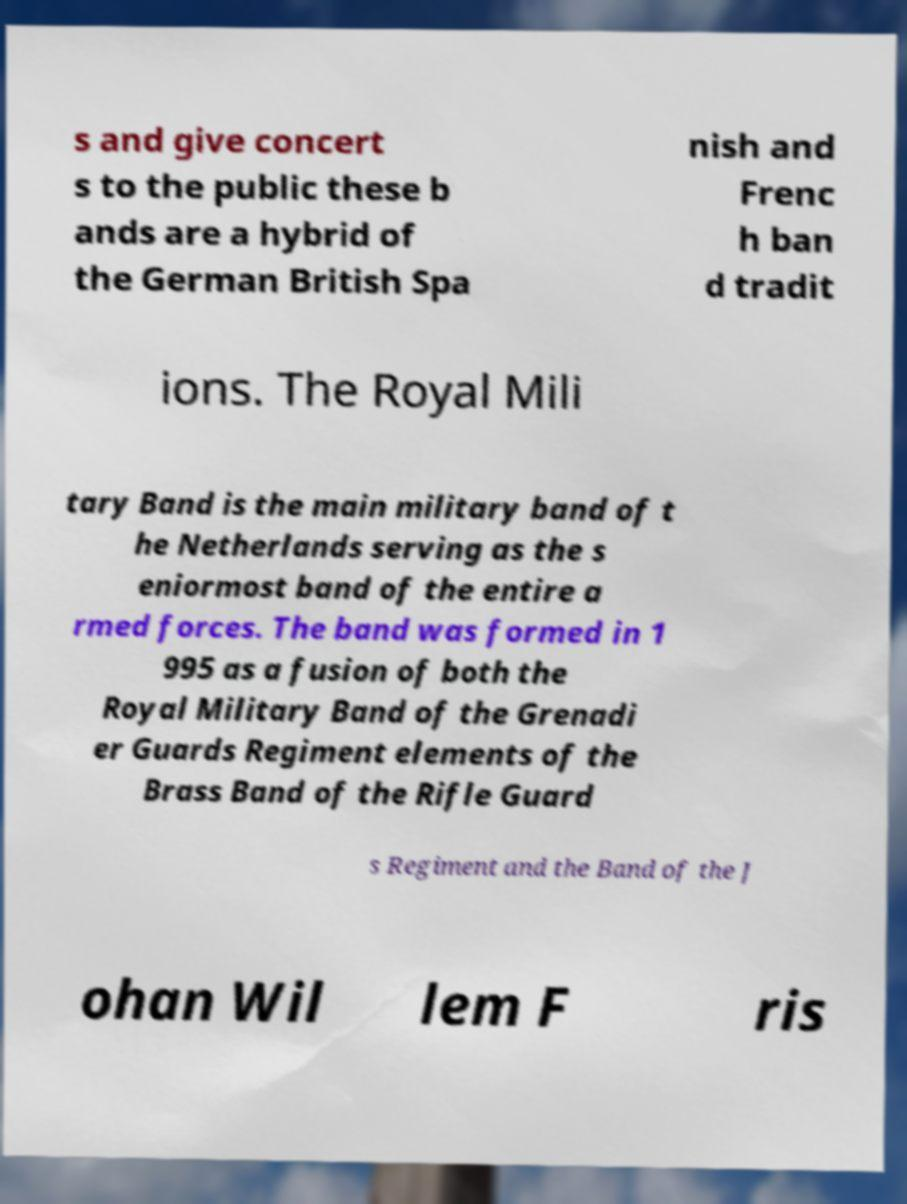I need the written content from this picture converted into text. Can you do that? s and give concert s to the public these b ands are a hybrid of the German British Spa nish and Frenc h ban d tradit ions. The Royal Mili tary Band is the main military band of t he Netherlands serving as the s eniormost band of the entire a rmed forces. The band was formed in 1 995 as a fusion of both the Royal Military Band of the Grenadi er Guards Regiment elements of the Brass Band of the Rifle Guard s Regiment and the Band of the J ohan Wil lem F ris 